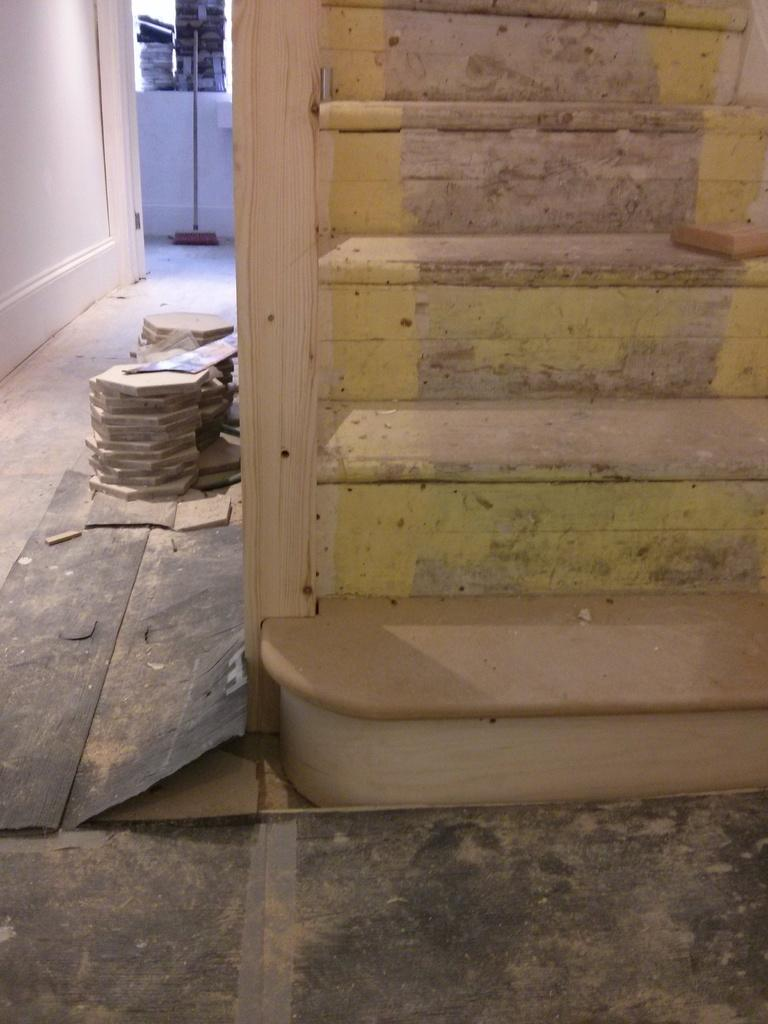What can be seen on the right side of the image? There are stairs on the right side of the image. What is located near the stairs? There are objects placed on the floor beside the stairs. What is on the left side of the image? There is a wall on the left side of the image. Can you see any protests happening in the image? There is no indication of a protest in the image. What part of the body is visible in the image? There are no body parts visible in the image. 